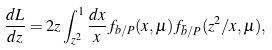Convert formula to latex. <formula><loc_0><loc_0><loc_500><loc_500>\frac { d L } { d z } = 2 z \int _ { z ^ { 2 } } ^ { 1 } \frac { d x } { x } f _ { b / P } ( x , \mu ) f _ { \bar { b } / P } ( z ^ { 2 } / x , \mu ) ,</formula> 